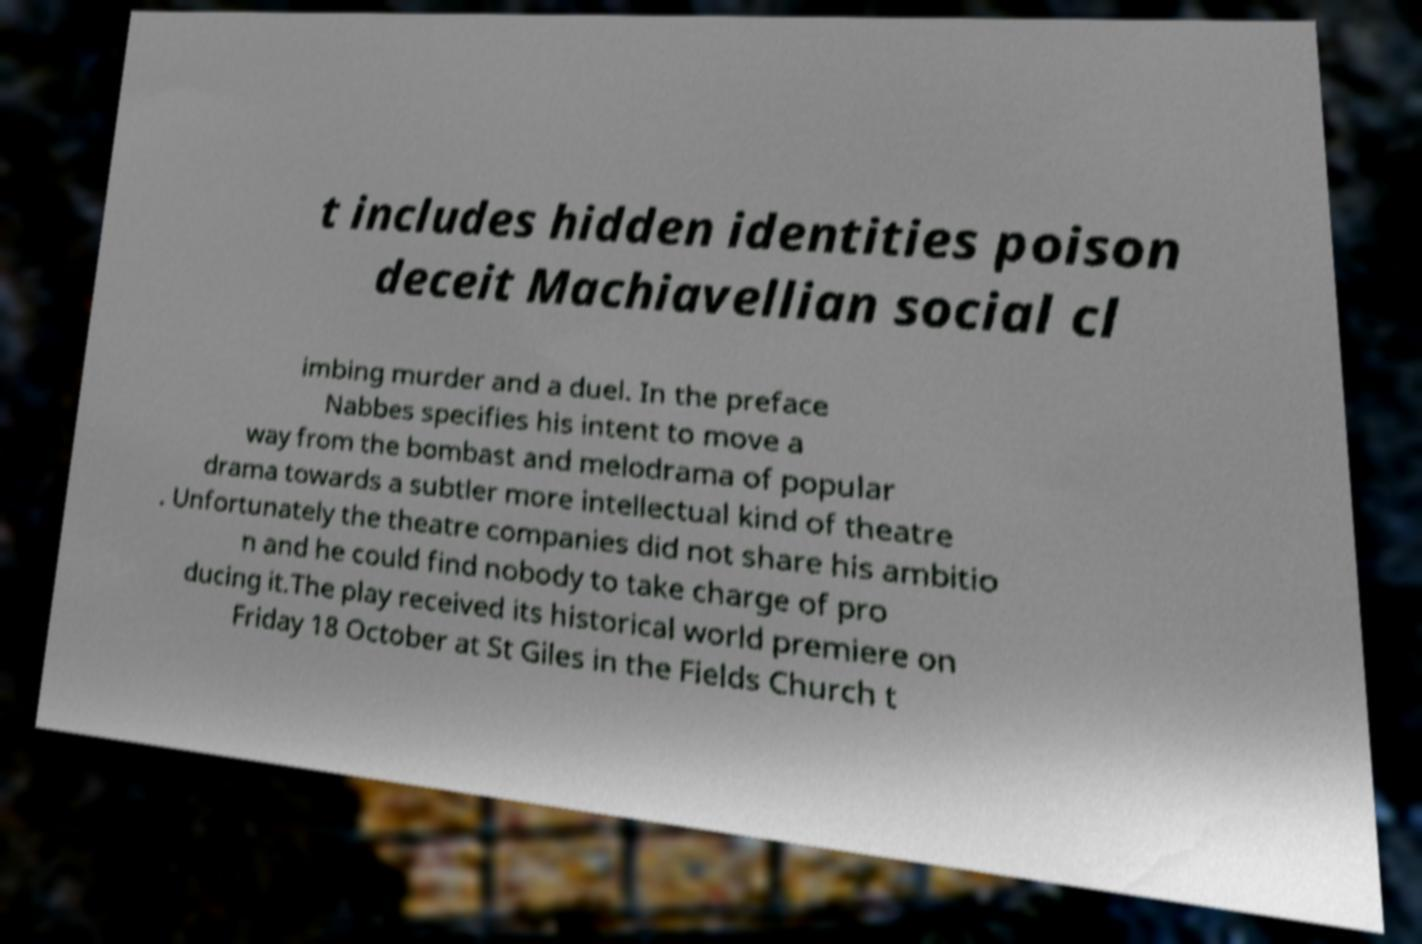There's text embedded in this image that I need extracted. Can you transcribe it verbatim? t includes hidden identities poison deceit Machiavellian social cl imbing murder and a duel. In the preface Nabbes specifies his intent to move a way from the bombast and melodrama of popular drama towards a subtler more intellectual kind of theatre . Unfortunately the theatre companies did not share his ambitio n and he could find nobody to take charge of pro ducing it.The play received its historical world premiere on Friday 18 October at St Giles in the Fields Church t 